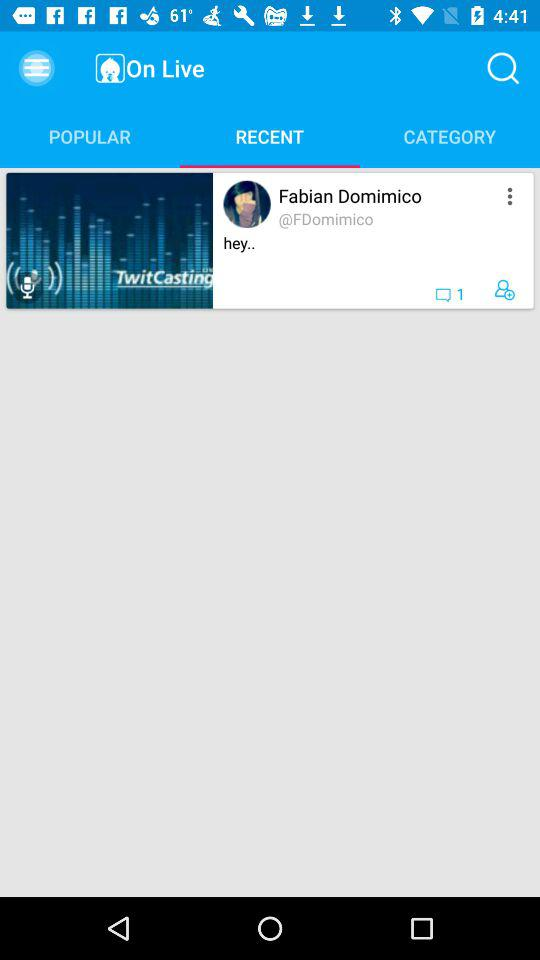What are the terms of service?
When the provided information is insufficient, respond with <no answer>. <no answer> 